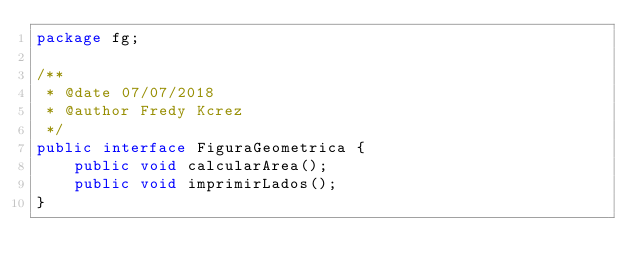<code> <loc_0><loc_0><loc_500><loc_500><_Java_>package fg;

/**
 * @date 07/07/2018
 * @author Fredy Kcrez
 */
public interface FiguraGeometrica {
    public void calcularArea();
    public void imprimirLados();
}</code> 